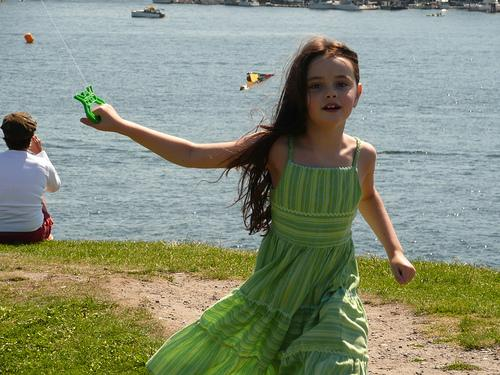Where is the nearest grass area to the girl in the image? The grass area is near the girl, to the left. Locate the person sitting close to the water in this image, and describe where they are. The person sitting close to the water is to the left, with a painting of 0,110,60,60. In a few words, describe the primary action happening in this image. Girl wearing striped dress sitting near water. What is the color of the stripes on the girl's dress? The stripes on the girl's dress are yellow. What small object can be seen on the water in this image? There is a buoy on the water. Briefly describe the environment of the image. The environment consists of a girl by the water, surrounded by grass, snow, trees, and dirt. What is the main focus of this image? The main focus is the girl near the water wearing a dress with yellow stripes. What object is the girl holding in her hand? The girl is holding a green plastic item. How can you describe the hair of the girl in the image? The girl has long hair on her head. Identify the largest element in the image representing the background. The body of water covering the background. 